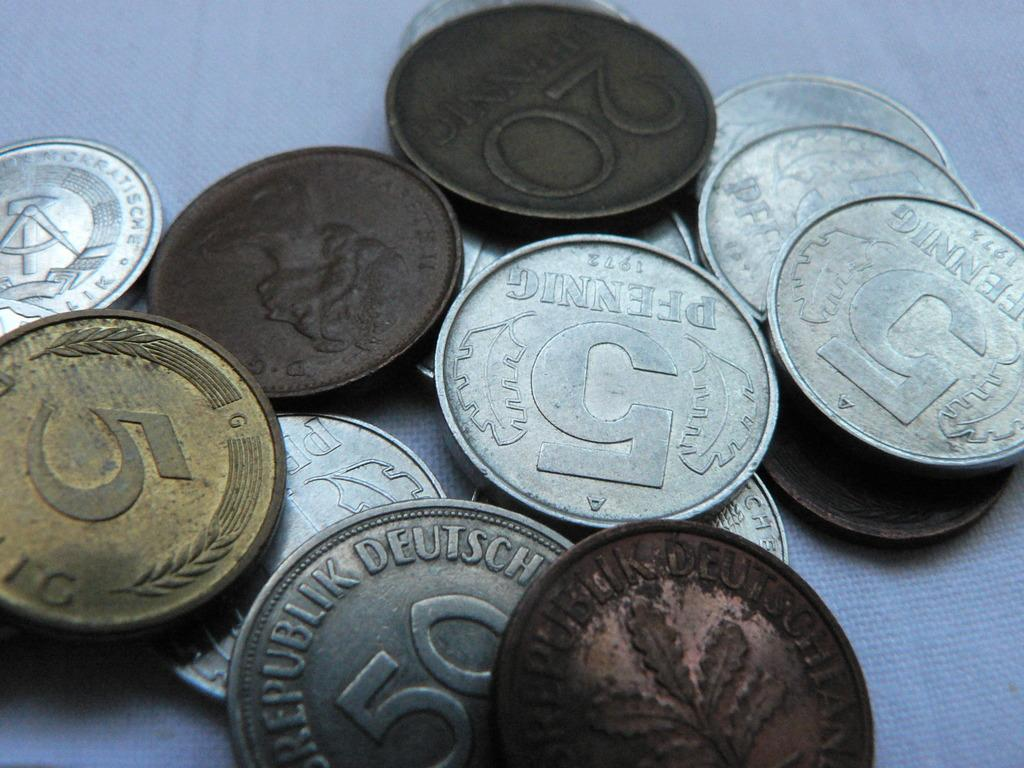<image>
Render a clear and concise summary of the photo. a coin that has the number 5 on one of its sides 